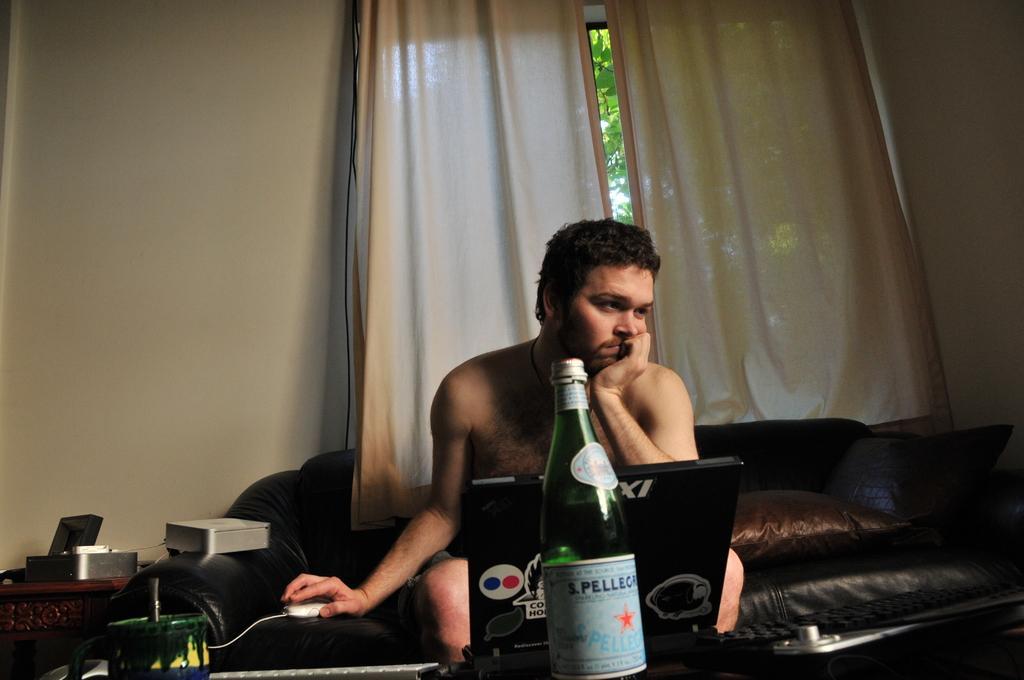Can you describe this image briefly? In this picture there is man sitting in the sofa and a pillow on the sofa. There is a laptop in front of a man and a bottle placed on the table. There is a mouse. In the background there is a curtain and a wall here. 